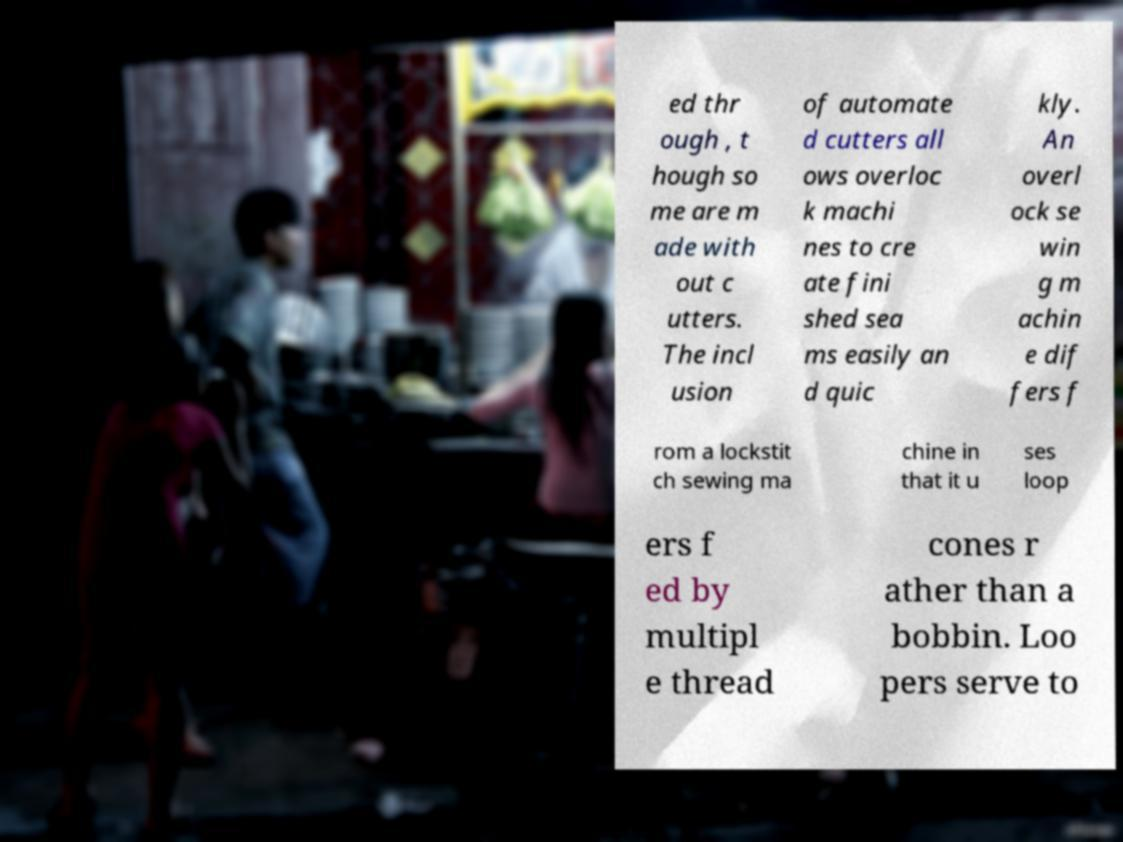Can you read and provide the text displayed in the image?This photo seems to have some interesting text. Can you extract and type it out for me? ed thr ough , t hough so me are m ade with out c utters. The incl usion of automate d cutters all ows overloc k machi nes to cre ate fini shed sea ms easily an d quic kly. An overl ock se win g m achin e dif fers f rom a lockstit ch sewing ma chine in that it u ses loop ers f ed by multipl e thread cones r ather than a bobbin. Loo pers serve to 